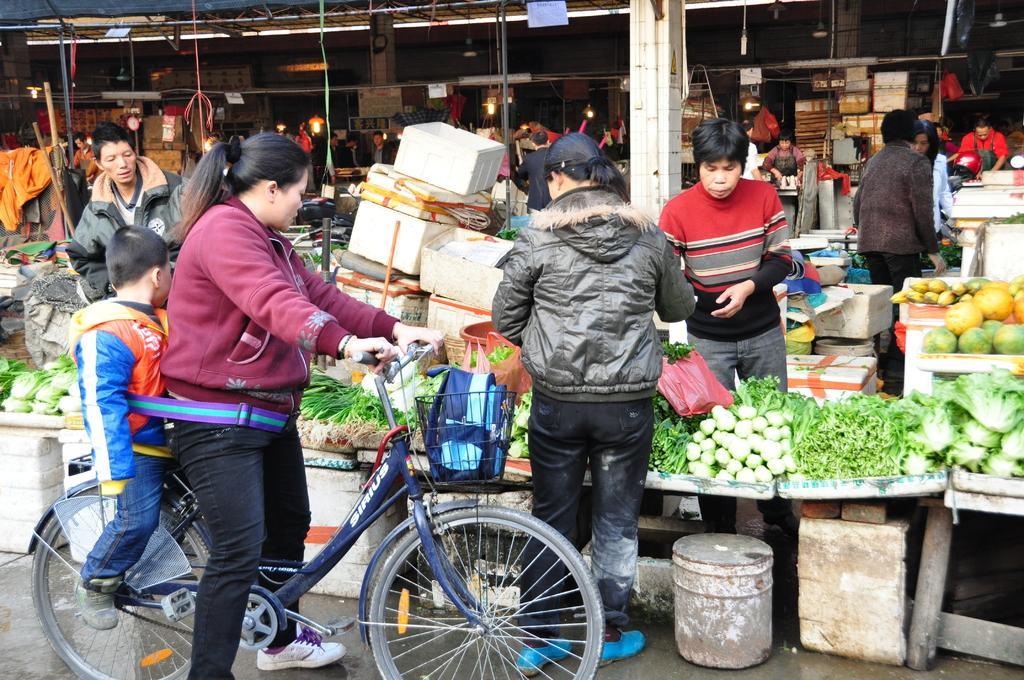Describe this image in one or two sentences. In the foreground, there are two person sitting on the bicycle. In the right group of people standing in front of the vegetable trays and in the left one person is standing. The tent is if bamboo sticks. In the middle a pillar is visible of white in color. There are different types of varieties of fruits and vegetables in the hall. It looks as if the image is taken inside a market. 